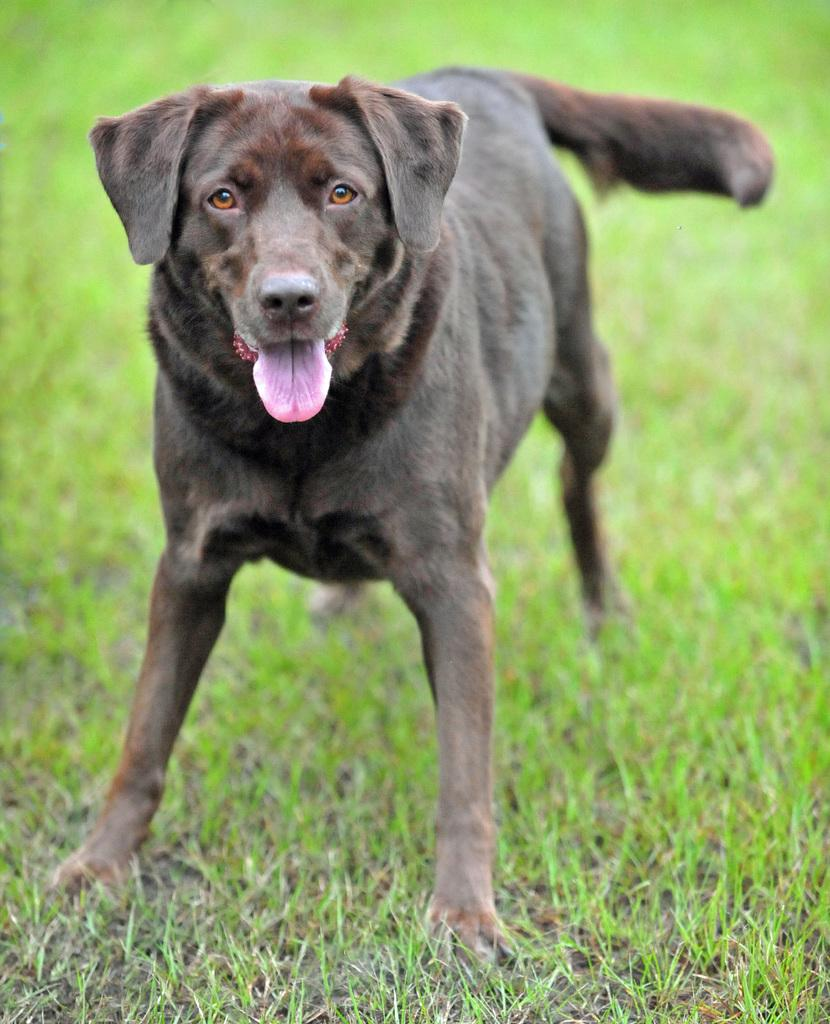What animal is in the image? There is a dog in the image. Where is the dog located in the image? The dog is in the center of the image. What type of terrain is the dog on? The dog is on a grassland. What type of thread is used to sew the quilt in the image? There is no quilt present in the image, so it is not possible to determine the type of thread used. 